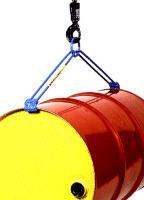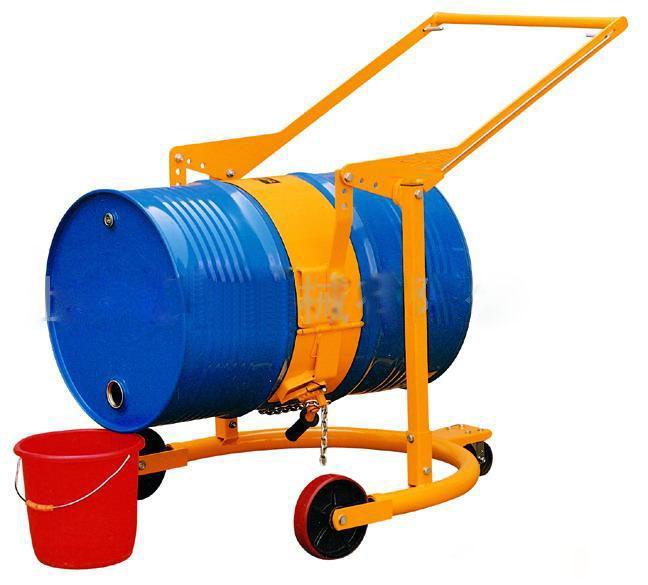The first image is the image on the left, the second image is the image on the right. Given the left and right images, does the statement "The barrels in the images are hanging horizontally." hold true? Answer yes or no. Yes. The first image is the image on the left, the second image is the image on the right. Considering the images on both sides, is "One image shows a barrel with a yellow end being hoisted by a blue lift that grips either end and is attached to a hook." valid? Answer yes or no. Yes. 